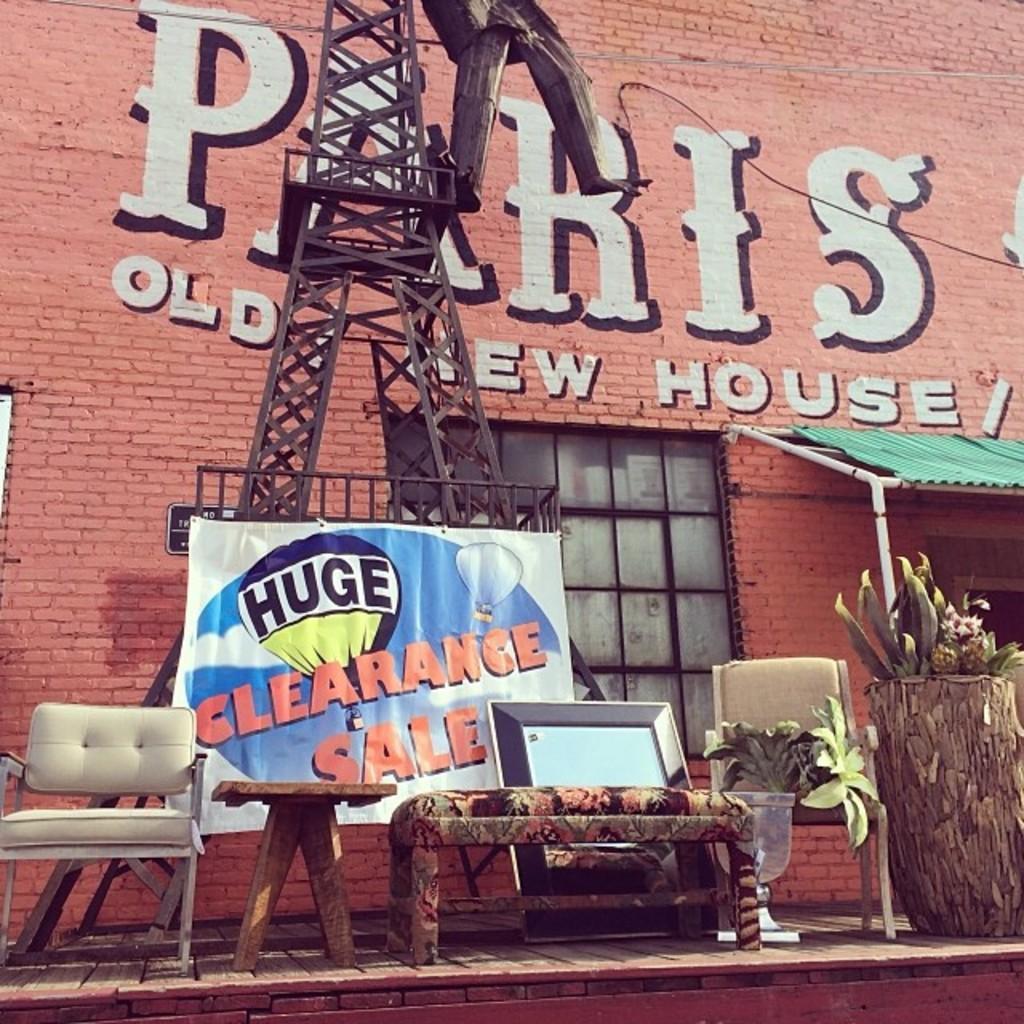Could you give a brief overview of what you see in this image? This picture is taken on the streets of a city. In the foreground of the picture there is a payment, on the payment they are chairs, table, couch and a plant. In the center there is a tower. In the background there is a wall, a window. 